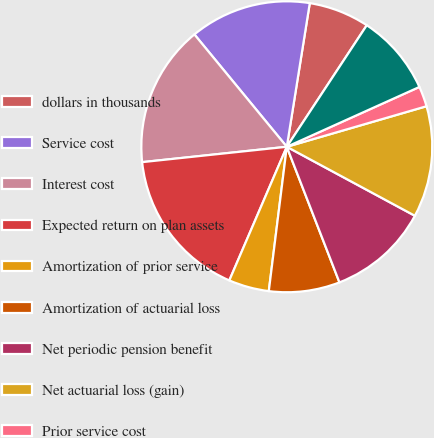Convert chart. <chart><loc_0><loc_0><loc_500><loc_500><pie_chart><fcel>dollars in thousands<fcel>Service cost<fcel>Interest cost<fcel>Expected return on plan assets<fcel>Amortization of prior service<fcel>Amortization of actuarial loss<fcel>Net periodic pension benefit<fcel>Net actuarial loss (gain)<fcel>Prior service cost<fcel>Reclassification of actuarial<nl><fcel>6.74%<fcel>13.48%<fcel>15.73%<fcel>16.85%<fcel>4.49%<fcel>7.87%<fcel>11.24%<fcel>12.36%<fcel>2.25%<fcel>8.99%<nl></chart> 